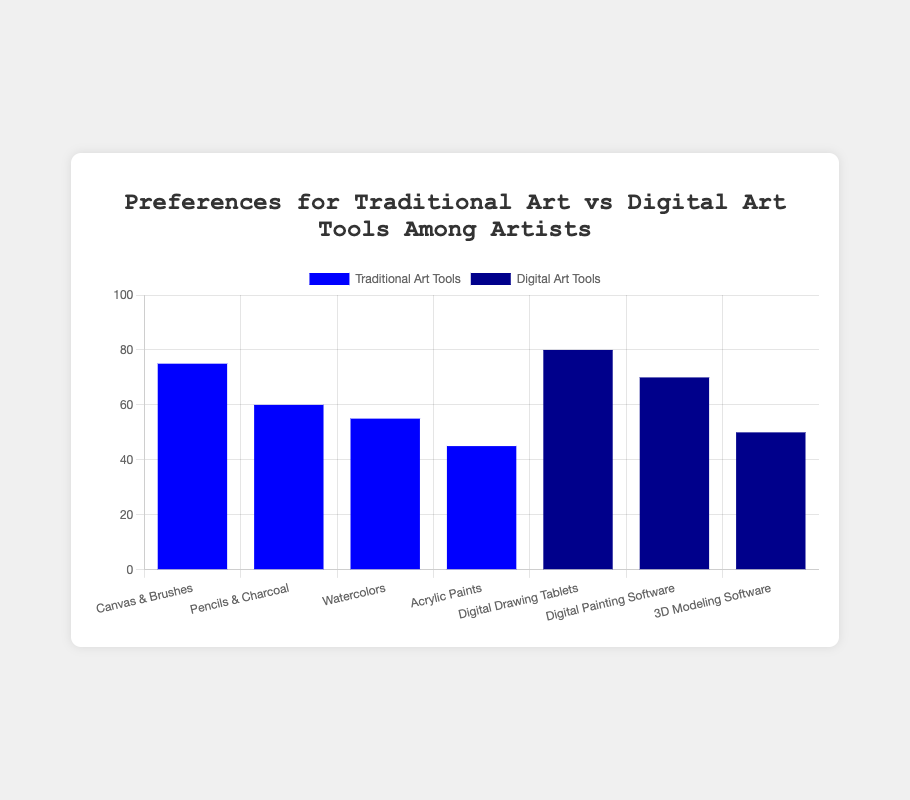Which type of art tool has the highest preference among artists? Look at the highest bar in the visual. The tallest bar corresponds to "Digital Drawing Tablets" under "Digital Art Tools" with a value of 80.
Answer: Digital Drawing Tablets How many more artists prefer Canvas & Brushes over Acrylic Paints? Find the values for "Canvas & Brushes" (75) and "Acrylic Paints" (45). Subtract the smaller value from the larger one: 75 - 45.
Answer: 30 Which traditional tool is the least preferred among artists? Check the values of all traditional tools and find the one with the lowest value. "Acrylic Paints" has the lowest value of 45.
Answer: Acrylic Paints What is the combined preference for Pencils & Charcoal and Watercolors? Add the values for "Pencils & Charcoal" (60) and "Watercolors" (55): 60 + 55.
Answer: 115 Are there any digital art tools that are preferred by more than 70 artists? Check all the bars under "Digital Art Tools". "Digital Drawing Tablets" has a preference of 80 and "Digital Painting Software" has a preference of 70, which fulfills the condition.
Answer: Yes Which has a higher preference: Digital Painting Software or 3D Modeling Software? Compare the heights of the bars. "Digital Painting Software" has a value of 70, whereas "3D Modeling Software" has a value of 50.
Answer: Digital Painting Software What is the average preference for Traditional Art Tools? Sum the values for all traditional tools (75 + 60 + 55 + 45 = 235) and divide by the number of traditional tools (4): 235 / 4.
Answer: 58.75 What is the total preference for all Digital Art Tools combined? Sum the values for all digital tools: 80 (Drawing Tablets) + 70 (Painting Software) + 50 (3D Modeling Software) = 200.
Answer: 200 Which color represents the Digital Art Tools category? Observe the bar colors and the corresponding legend. The digital tools bars are in dark blue.
Answer: Dark blue Comparing Traditional Art Tools, what is the difference in preference between Pencils & Charcoal and Watercolors? Find the values for "Pencils & Charcoal" (60) and "Watercolors" (55). Subtract the smaller value from the larger one: 60 - 55.
Answer: 5 